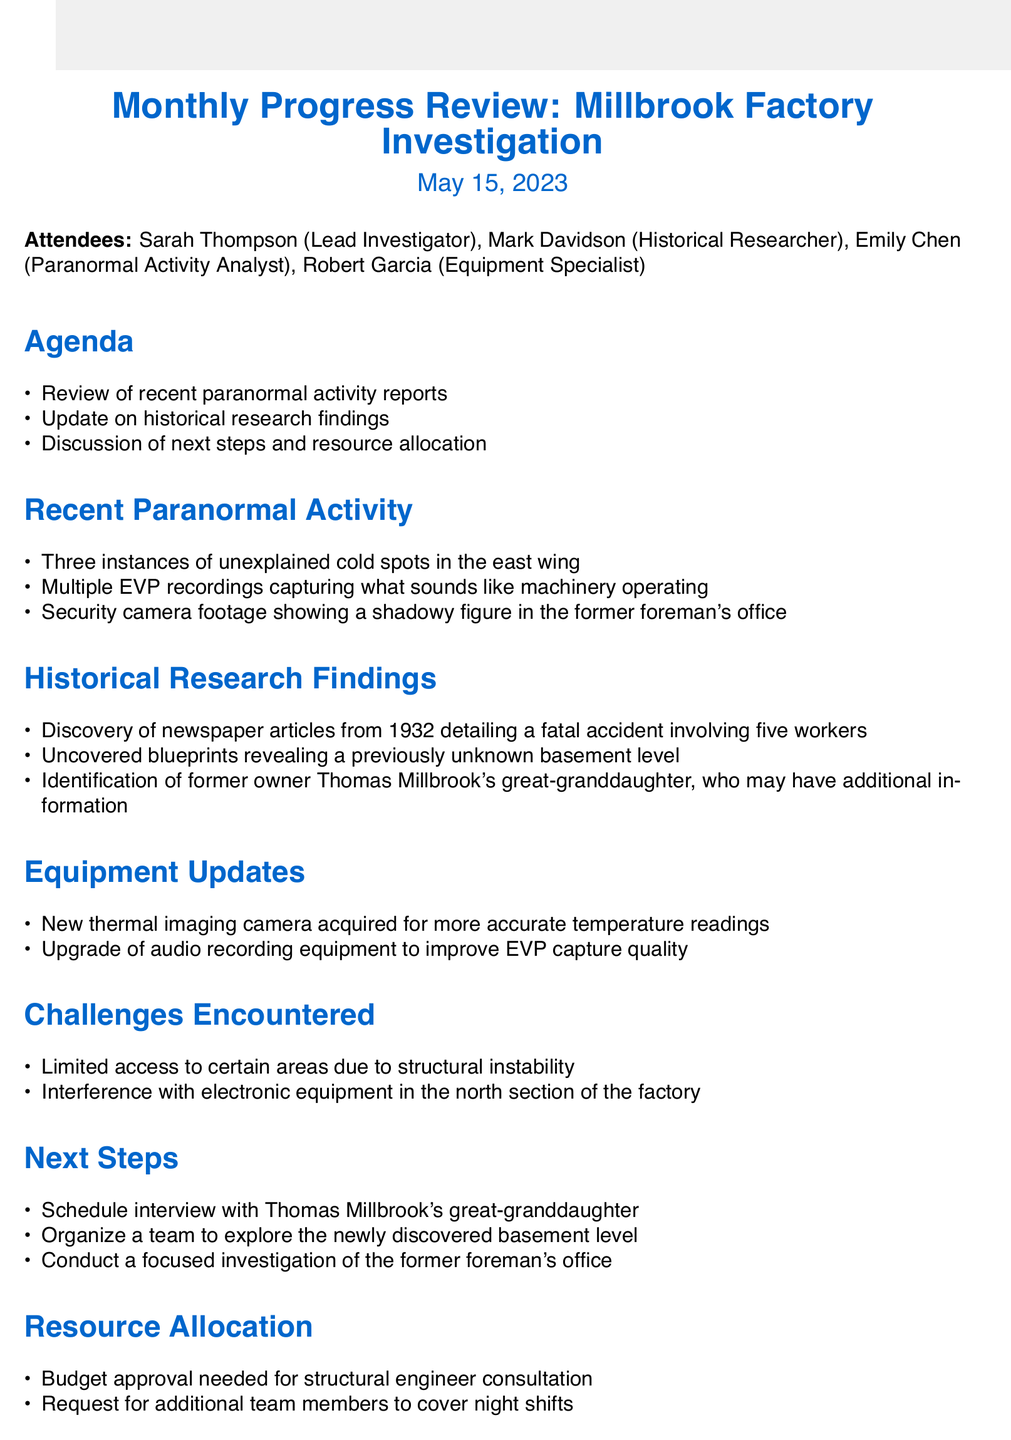What is the date of the meeting? The meeting date is clearly stated at the beginning of the document, which is May 15, 2023.
Answer: May 15, 2023 Who is the Lead Investigator? The document lists the attendees, identifying Sarah Thompson as the Lead Investigator.
Answer: Sarah Thompson How many instances of unexplained cold spots were reported? The document lists three instances of unexplained cold spots in the recent paranormal activity section.
Answer: Three What year was the fatal accident involving five workers reported in newspaper articles? Historical research findings mention the year 1932 in relation to the fatal accident.
Answer: 1932 What new equipment was acquired for the investigation? The document specifies that a new thermal imaging camera was acquired for temperature readings.
Answer: Thermal imaging camera What is a challenge faced during the investigation? The challenges encountered section mentions limited access to certain areas due to structural instability.
Answer: Structural instability What are the next steps outlined in the investigation? The next steps include scheduling an interview with Thomas Millbrook's great-granddaughter.
Answer: Interview with Thomas Millbrook's great-granddaughter What is needed for resource allocation regarding structural engineers? The document states that budget approval is needed for structural engineer consultation.
Answer: Budget approval How many attendees were present at the meeting? The attendees list mentions four individuals present at the meeting.
Answer: Four 